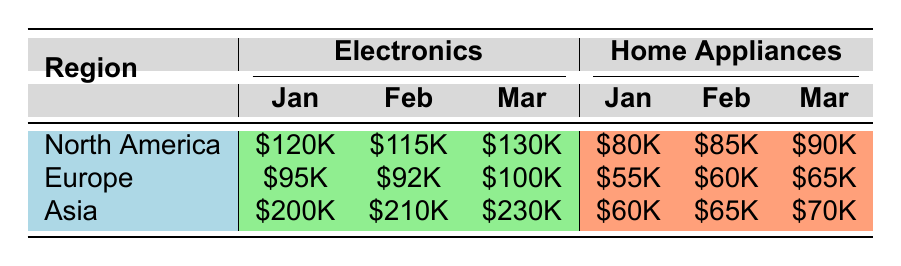What was the total revenue from Electronic sales in North America for January? To find the total revenue from Electronic sales in North America for January, we look at the table and find that the revenue is $120,000.
Answer: $120,000 Which region had the highest revenue from Home Appliances in March? In March, the Home Appliances revenue for each region is: North America - $90,000, Europe - $65,000, Asia - $70,000. The highest revenue is from North America.
Answer: North America What is the difference in revenue from Electronics between Asia and Europe for February? For February, Electronics revenue for Asia is $210,000 and for Europe is $92,000. The difference is $210,000 - $92,000 = $118,000.
Answer: $118,000 Did North America generate more revenue from Electronics in March than in January? For North America, Electronics revenue in March is $130,000 while in January it was $120,000. Since $130,000 is greater than $120,000, the answer is yes.
Answer: Yes What is the average revenue from Home Appliances across all regions for January? The revenues for January are: North America - $80,000, Europe - $55,000, Asia - $60,000. The total is $80,000 + $55,000 + $60,000 = $195,000. The average is $195,000 / 3 = $65,000.
Answer: $65,000 Which product category contributed more to overall revenue in February: Electronics or Home Appliances? Total revenue for Electronics in February is $210,000 (Asia) + $92,000 (Europe) + $115,000 (North America) = $417,000. Total for Home Appliances is $65,000 (Asia) + $60,000 (Europe) + $85,000 (North America) = $210,000. Since $417,000 is greater than $210,000, Electronics contributed more.
Answer: Electronics What was the total revenue for Asia from both product categories in March? In March, for Asia, Electronics revenue is $230,000 and Home Appliances revenue is $70,000. Total revenue is $230,000 + $70,000 = $300,000.
Answer: $300,000 Is the revenue from Home Appliances in North America for February more than that in Europe? For February, Home Appliances revenue in North America is $85,000 while in Europe it is $60,000. Since $85,000 is greater than $60,000, the answer is yes.
Answer: Yes What was the percentage increase in Electronics revenue from January to March in Asia? In January, Electronics revenue in Asia was $200,000 and in March it was $230,000. The increase is $230,000 - $200,000 = $30,000. The percentage increase is ($30,000 / $200,000) * 100% = 15%.
Answer: 15% 